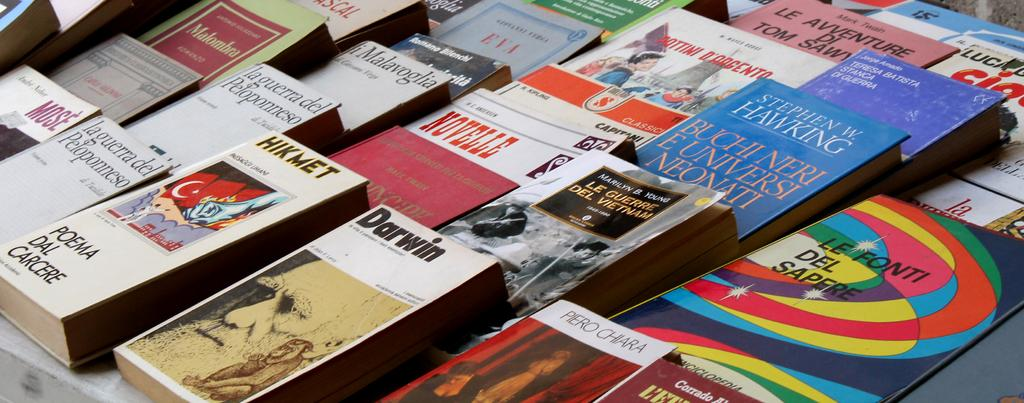<image>
Summarize the visual content of the image. many books lined up include Stephen Hawking and Darwin 